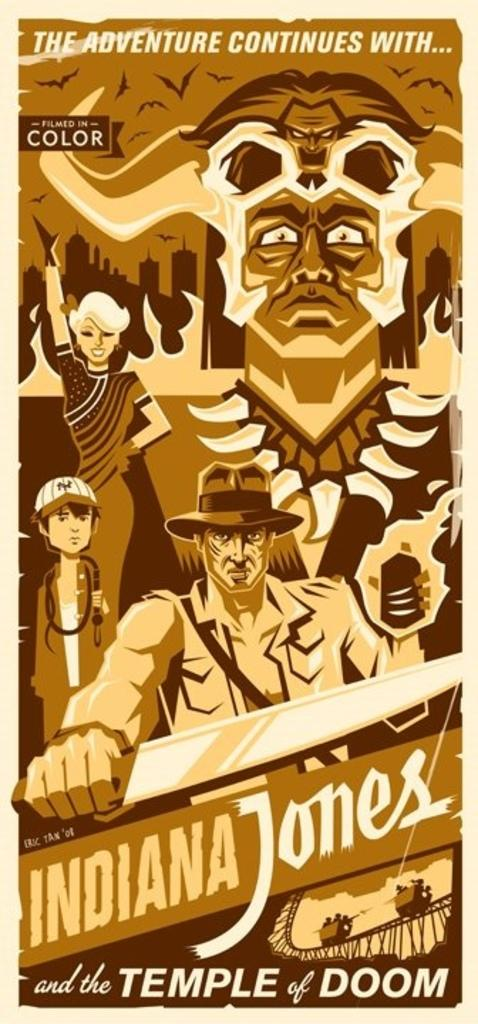<image>
Present a compact description of the photo's key features. An animated Poster of the movie of Indiana Jones and the Temple of Doom 